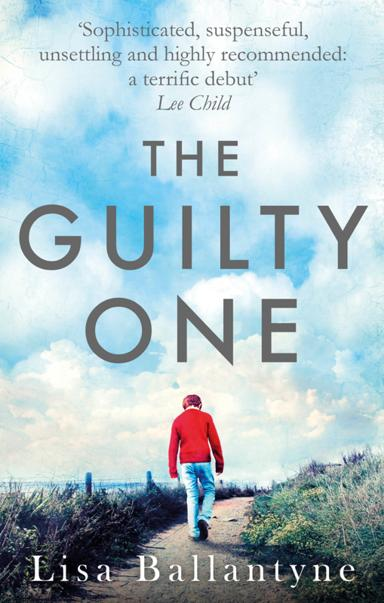What is the title of the recommended book in the image? The book showcased in the image is titled 'The Guilty One' authored by Lisa Ballantyne. The cover art, featuring a lone figure walking away on a path with dramatic sky above, hints at the intriguing themes of conflict and redemption that unfold in this compelling narrative. 